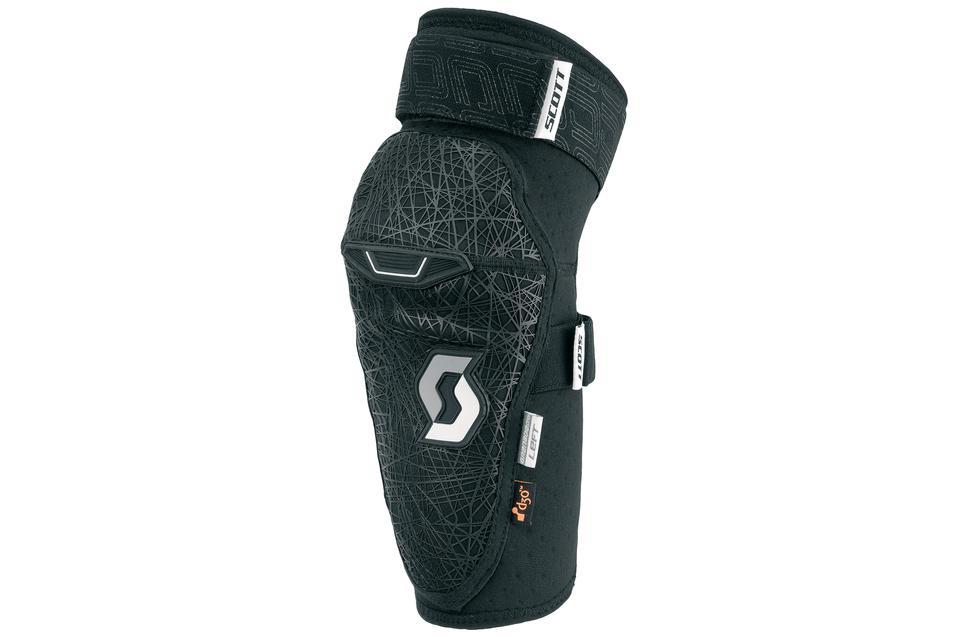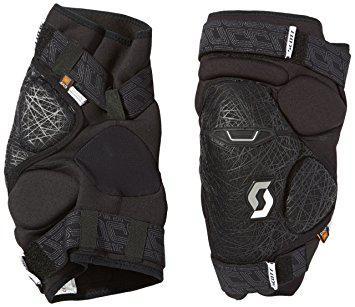The first image is the image on the left, the second image is the image on the right. For the images shown, is this caption "The knee guards are being worn by a person in one of the images." true? Answer yes or no. No. The first image is the image on the left, the second image is the image on the right. Considering the images on both sides, is "The left image features an unworn black knee pad, while the right image shows a pair of human legs wearing a pair of black knee pads." valid? Answer yes or no. No. 